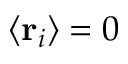Convert formula to latex. <formula><loc_0><loc_0><loc_500><loc_500>\langle r _ { i } \rangle = 0</formula> 